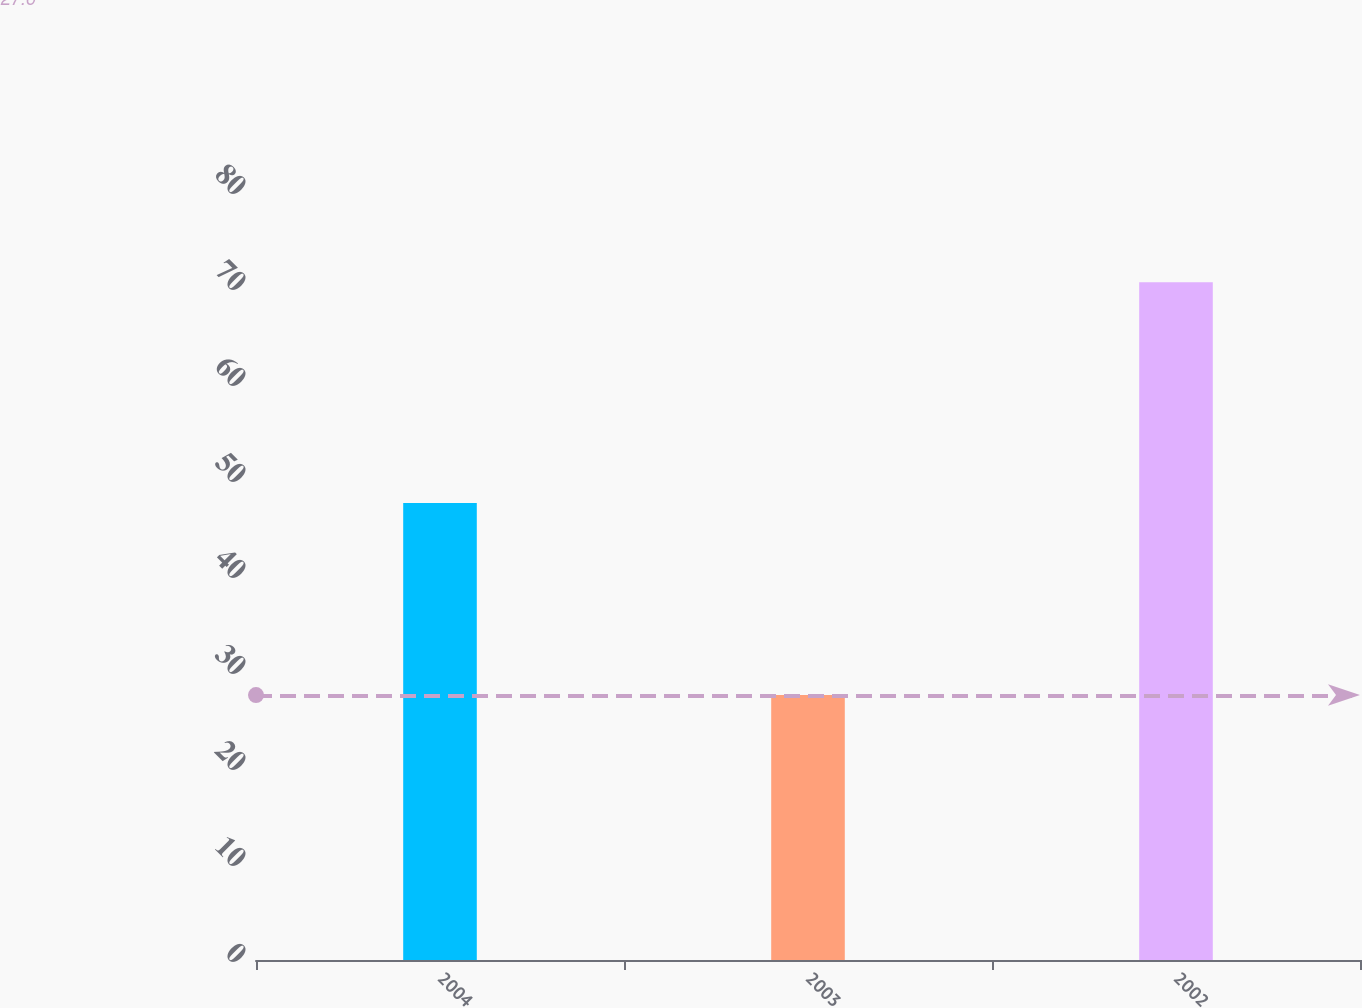Convert chart to OTSL. <chart><loc_0><loc_0><loc_500><loc_500><bar_chart><fcel>2004<fcel>2003<fcel>2002<nl><fcel>47.6<fcel>27.6<fcel>70.6<nl></chart> 